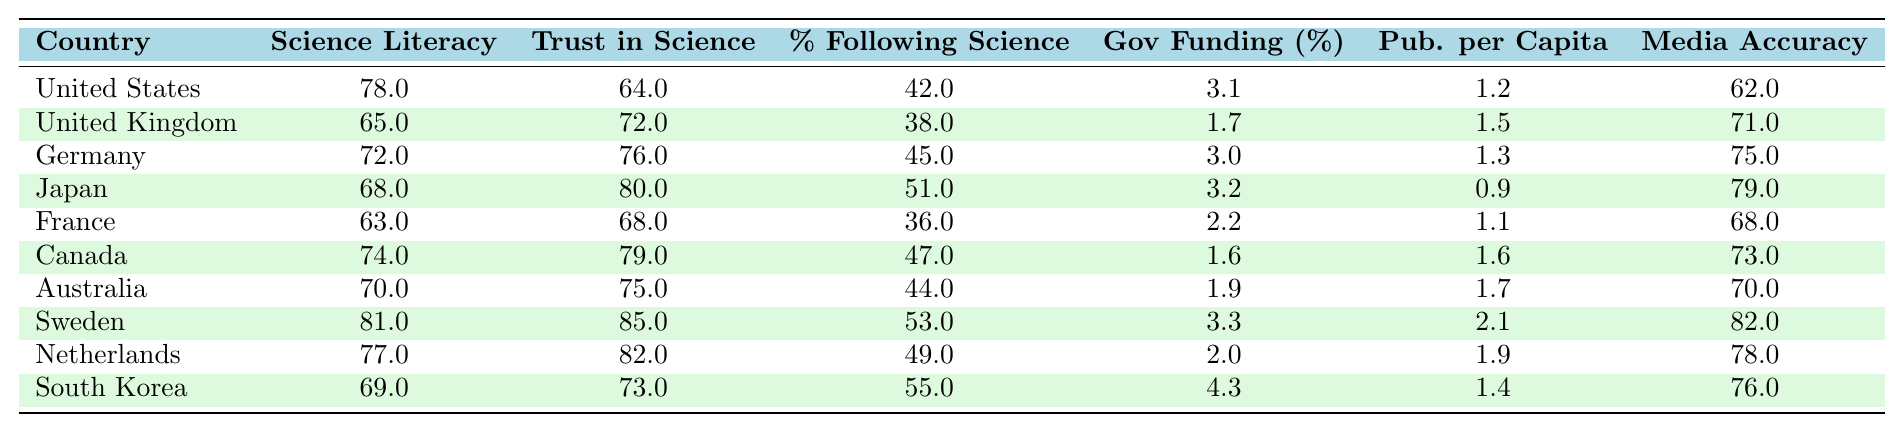What is the science literacy score of Sweden? The table shows the science literacy score for each country listed. Sweden is located in the table, and its corresponding score is 81.
Answer: 81 Which country has the highest trust in scientific institutions? Looking at the trust in scientific institutions column, Sweden has the highest value at 85.
Answer: Sweden What is the percentage of people following science news in Canada? The table lists Canada's percentage of people following science news as 47%.
Answer: 47 Calculate the average trust in scientific institutions for all listed countries. First, sum the trust values: (64 + 72 + 76 + 80 + 68 + 79 + 75 + 85 + 82 + 73) =  794. Then, divide by the number of countries (10): 794 / 10 = 79.4.
Answer: 79.4 Is the government funding for science in the Netherlands higher than the average for all countries? First, find the average government funding: (3.1 + 1.7 + 3.0 + 3.2 + 2.2 + 1.6 + 1.9 + 3.3 + 2.0 + 4.3) =  24.3; then divide by 10, resulting in 2.43. The Netherlands has 2.0, which is less than 2.43.
Answer: No What is the difference between Japan's and Germany's science literacy scores? Japan's score is 68 and Germany's score is 72. The difference is 72 - 68 = 4.
Answer: 4 Which country has the lowest media accuracy in science reporting? By examining the media accuracy column, France has the lowest value at 68.
Answer: France Is there a correlation between higher science literacy scores and higher trust in scientific institutions among these countries? This would require observing trends in the data. Higher science literacy scores correspond with higher trust values in countries like Germany and the UK. Conversely, France shows lower literacy and trust. Thus, there appears to be a correlation.
Answer: Yes What is the total number of scientific publications per capita for all listed countries? Sum the publications per capita: (1.2 + 1.5 + 1.3 + 0.9 + 1.1 + 1.6 + 1.7 + 2.1 + 1.9 + 1.4) = 14.7.
Answer: 14.7 What is the ratio of the highest percentage following science news to the lowest percentage? The highest percentage is in South Korea (55%) and the lowest is in France (36%). The ratio is 55:36, which simplifies to approximately 1.53:1.
Answer: 1.53:1 